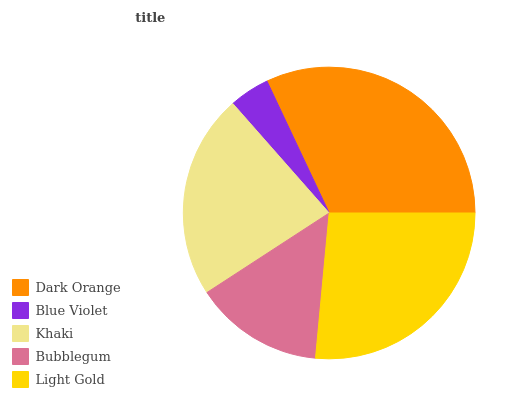Is Blue Violet the minimum?
Answer yes or no. Yes. Is Dark Orange the maximum?
Answer yes or no. Yes. Is Khaki the minimum?
Answer yes or no. No. Is Khaki the maximum?
Answer yes or no. No. Is Khaki greater than Blue Violet?
Answer yes or no. Yes. Is Blue Violet less than Khaki?
Answer yes or no. Yes. Is Blue Violet greater than Khaki?
Answer yes or no. No. Is Khaki less than Blue Violet?
Answer yes or no. No. Is Khaki the high median?
Answer yes or no. Yes. Is Khaki the low median?
Answer yes or no. Yes. Is Dark Orange the high median?
Answer yes or no. No. Is Bubblegum the low median?
Answer yes or no. No. 